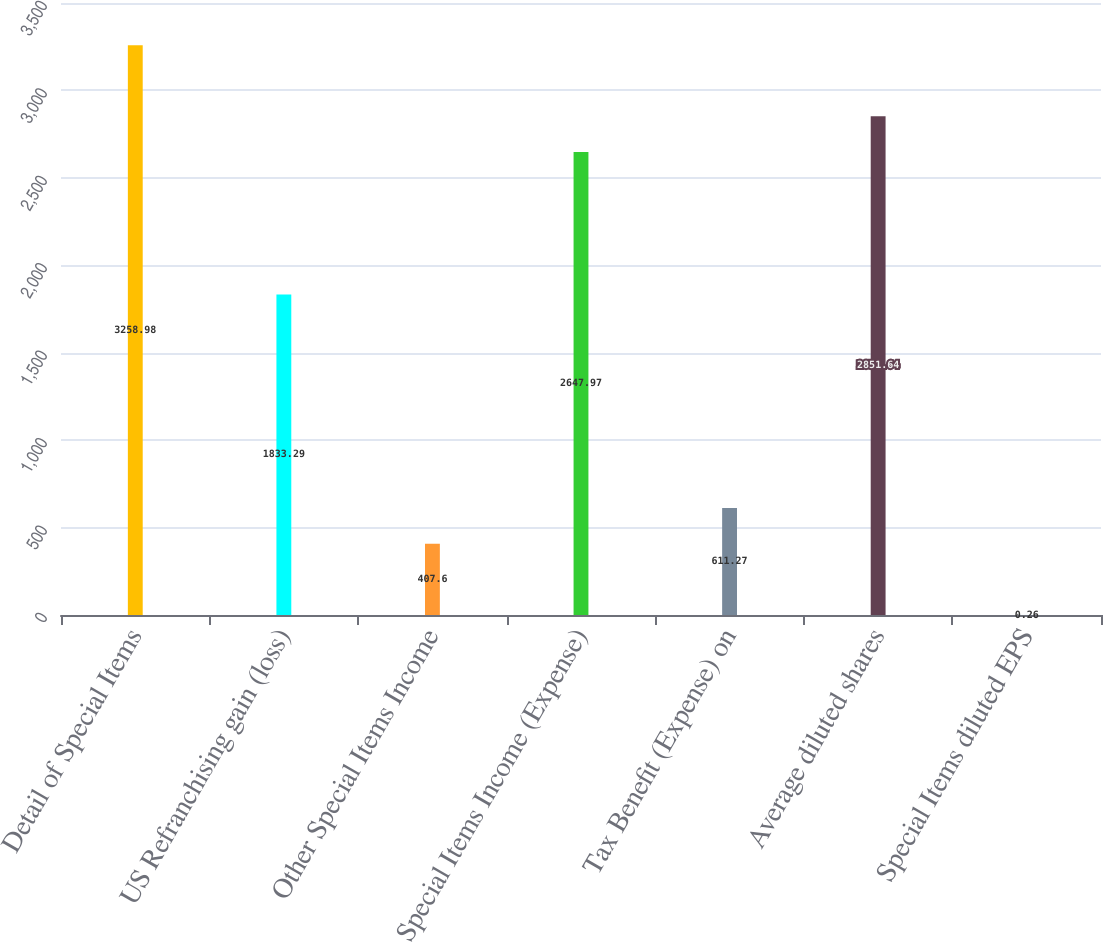Convert chart. <chart><loc_0><loc_0><loc_500><loc_500><bar_chart><fcel>Detail of Special Items<fcel>US Refranchising gain (loss)<fcel>Other Special Items Income<fcel>Special Items Income (Expense)<fcel>Tax Benefit (Expense) on<fcel>Average diluted shares<fcel>Special Items diluted EPS<nl><fcel>3258.98<fcel>1833.29<fcel>407.6<fcel>2647.97<fcel>611.27<fcel>2851.64<fcel>0.26<nl></chart> 